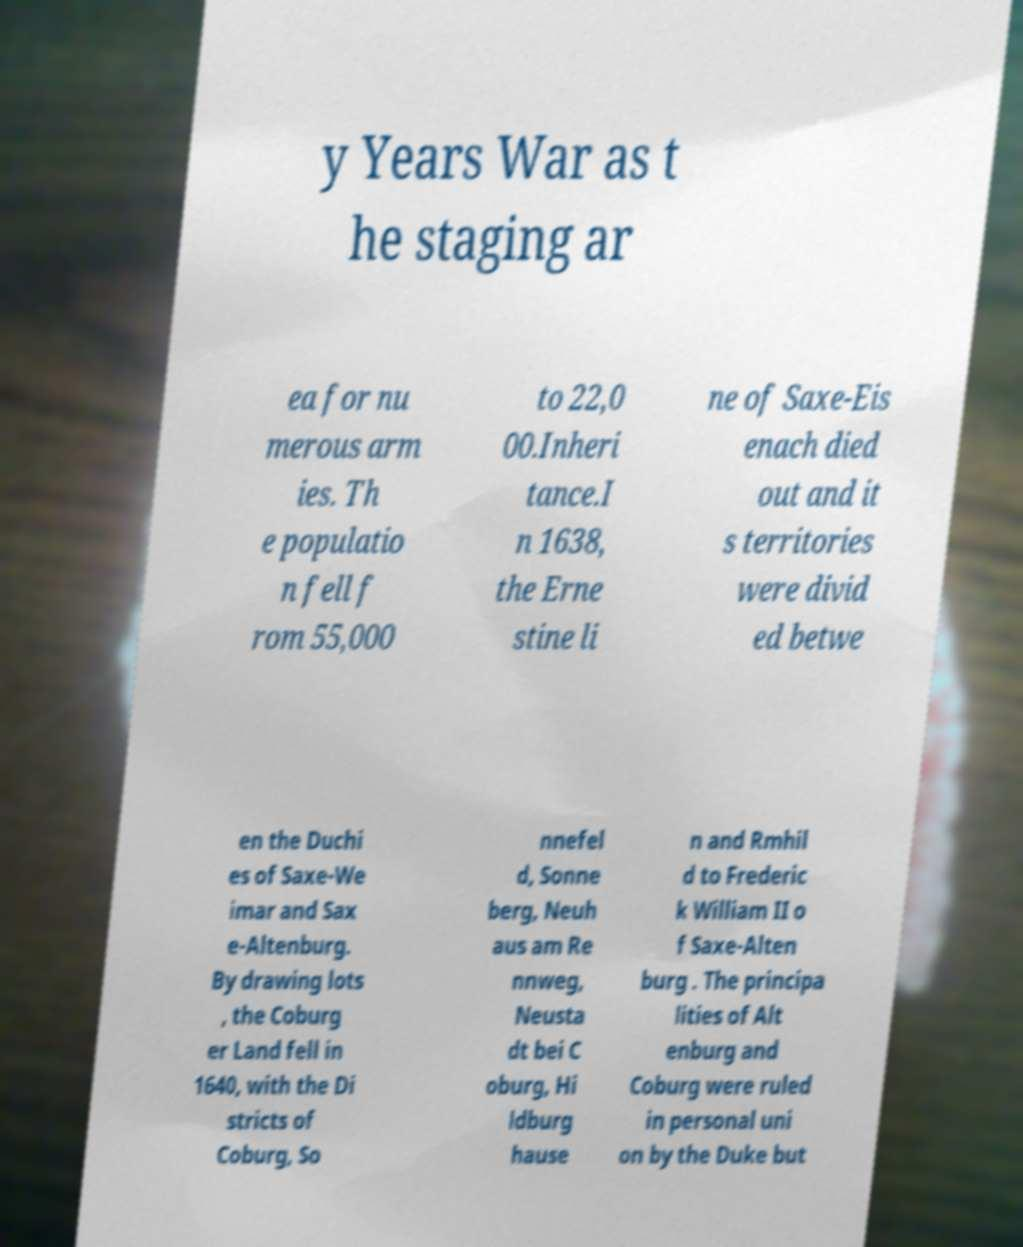Can you accurately transcribe the text from the provided image for me? y Years War as t he staging ar ea for nu merous arm ies. Th e populatio n fell f rom 55,000 to 22,0 00.Inheri tance.I n 1638, the Erne stine li ne of Saxe-Eis enach died out and it s territories were divid ed betwe en the Duchi es of Saxe-We imar and Sax e-Altenburg. By drawing lots , the Coburg er Land fell in 1640, with the Di stricts of Coburg, So nnefel d, Sonne berg, Neuh aus am Re nnweg, Neusta dt bei C oburg, Hi ldburg hause n and Rmhil d to Frederic k William II o f Saxe-Alten burg . The principa lities of Alt enburg and Coburg were ruled in personal uni on by the Duke but 